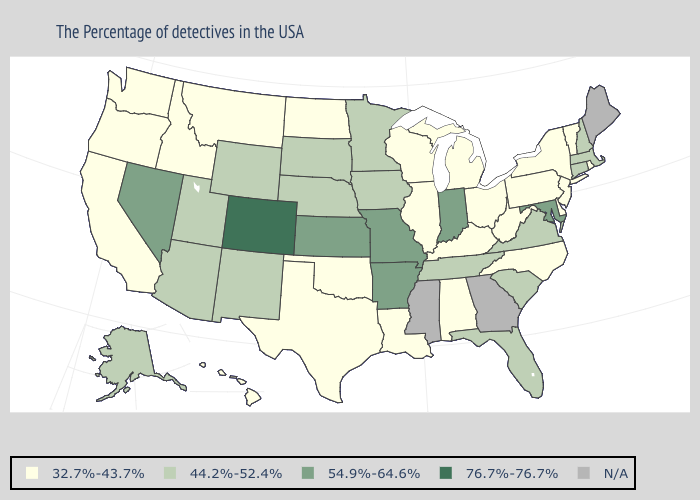What is the lowest value in the USA?
Keep it brief. 32.7%-43.7%. Which states have the lowest value in the South?
Quick response, please. Delaware, North Carolina, West Virginia, Kentucky, Alabama, Louisiana, Oklahoma, Texas. Which states have the lowest value in the Northeast?
Short answer required. Rhode Island, Vermont, New York, New Jersey, Pennsylvania. Is the legend a continuous bar?
Answer briefly. No. Name the states that have a value in the range 76.7%-76.7%?
Keep it brief. Colorado. Does Texas have the lowest value in the USA?
Concise answer only. Yes. Is the legend a continuous bar?
Concise answer only. No. Does Montana have the lowest value in the USA?
Give a very brief answer. Yes. What is the value of Massachusetts?
Short answer required. 44.2%-52.4%. Among the states that border Minnesota , does Iowa have the highest value?
Be succinct. Yes. Name the states that have a value in the range 54.9%-64.6%?
Be succinct. Maryland, Indiana, Missouri, Arkansas, Kansas, Nevada. Is the legend a continuous bar?
Short answer required. No. What is the value of New York?
Answer briefly. 32.7%-43.7%. 